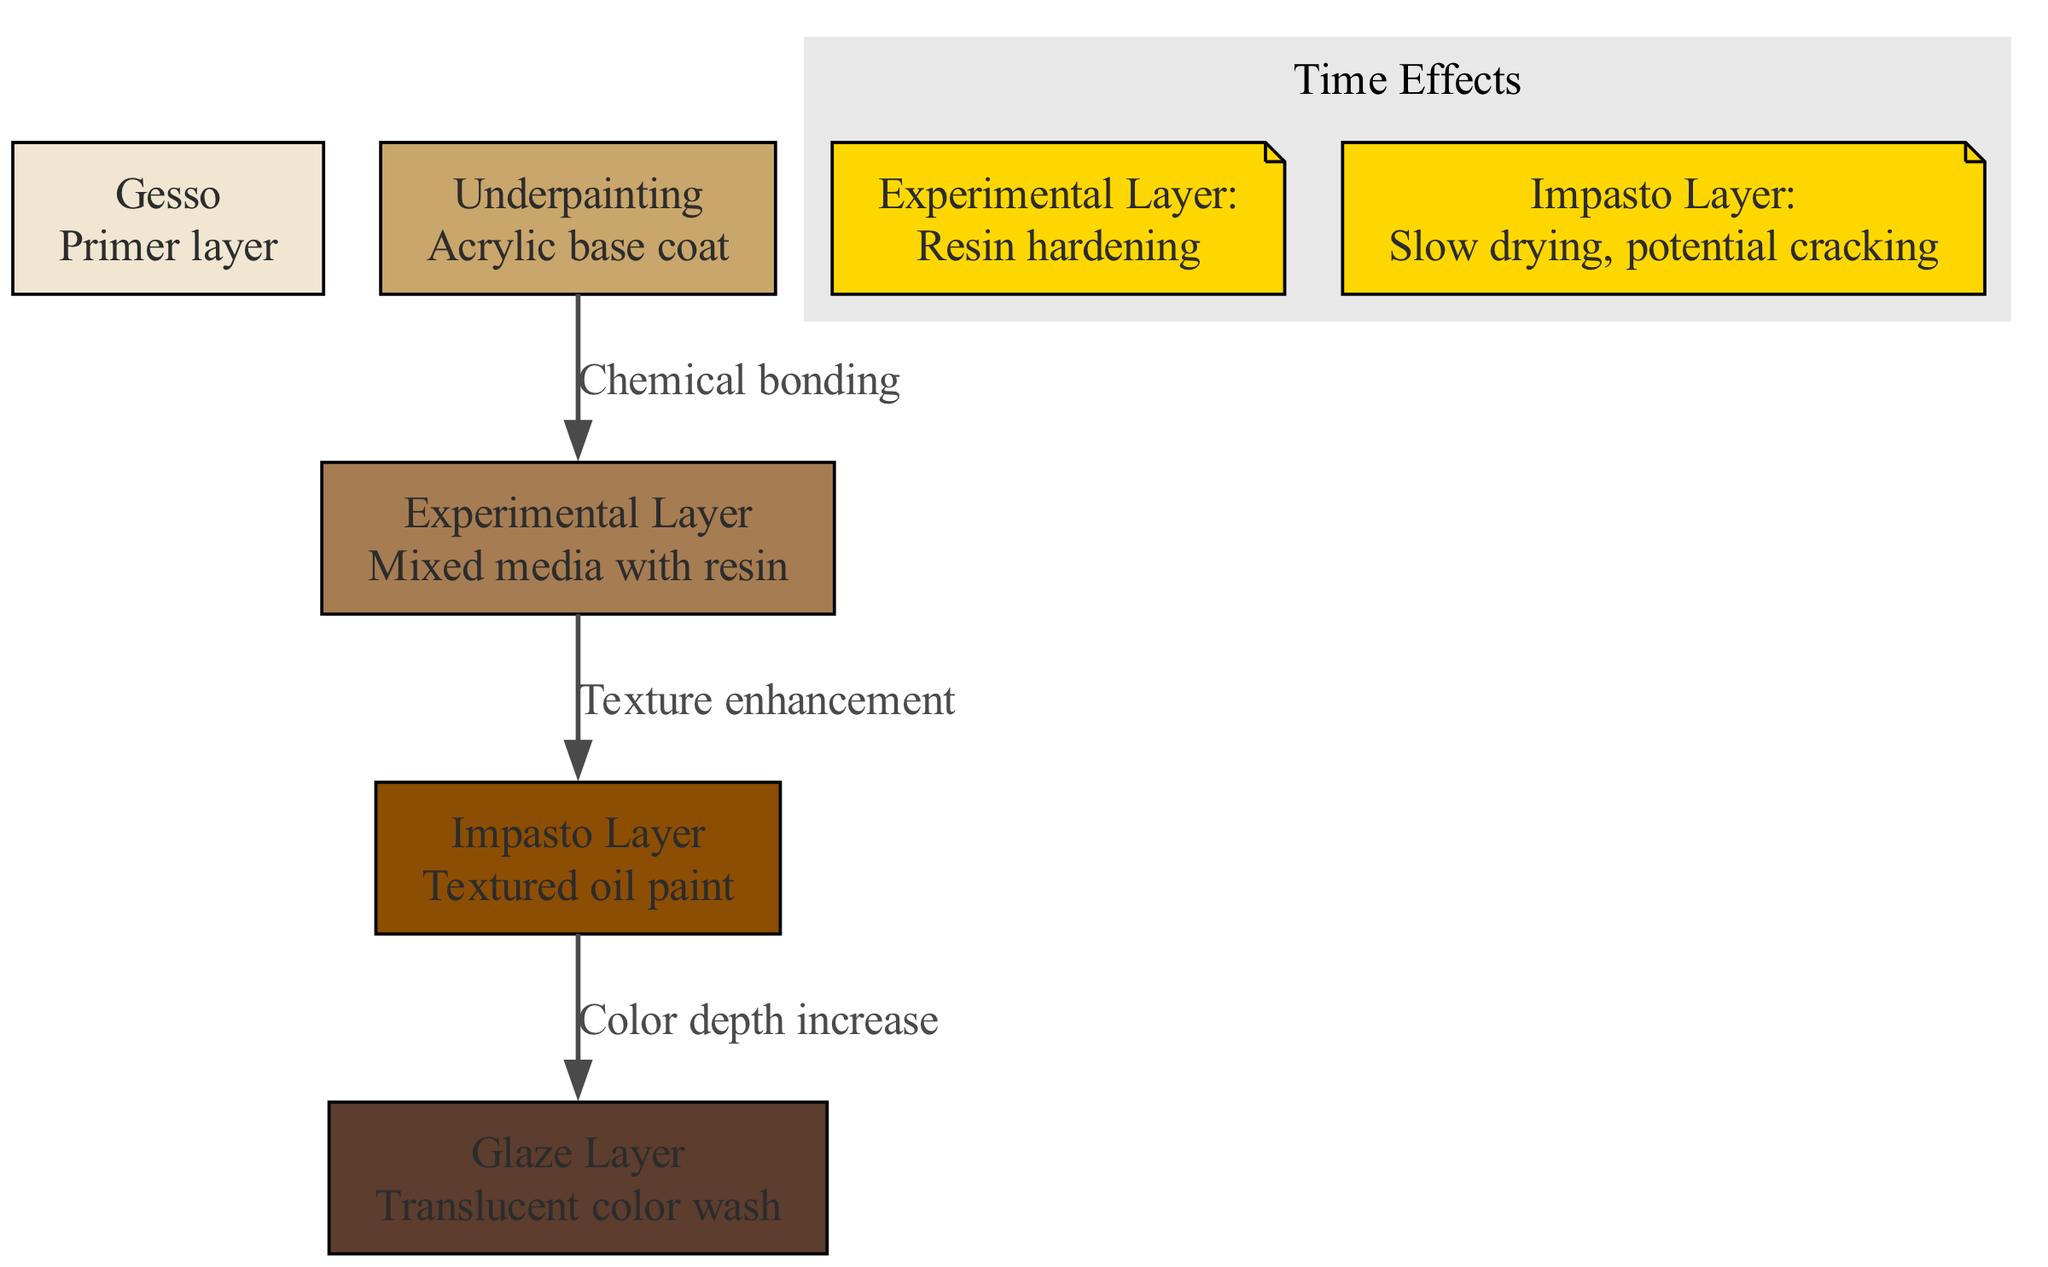What is the primer layer in the canvas cross-section? The primer layer is identified in the diagram as "Gesso." It is the base layer that prepares the canvas for subsequent layers of paint.
Answer: Gesso How many layers are there in total? The diagram lists five distinct layers in the canvas. This can be counted directly from the nodes representing each layer.
Answer: 5 What interaction occurs between the Underpainting and the Experimental Layer? The interaction label between these two layers states "Chemical bonding." This shows a key relationship that affects how these layers adhere to each other, which is visible in the edge label.
Answer: Chemical bonding Which layer is associated with slow drying and potential cracking? According to the "Time Effects" subgraph in the diagram, the "Impasto Layer" is noted for having slow drying and potential cracking over time.
Answer: Impasto Layer What is the effect of the interaction between the Impasto Layer and the Glaze Layer? The interaction between these two layers is defined in the diagram as "Color depth increase," which indicates how these layers enhance the visual quality of the painting.
Answer: Color depth increase Which layer introduces a mixed media with resin? The layer referred to in the diagram as "Experimental Layer" is noted for using mixed media incorporating resin, distinguishing its composition from other layers.
Answer: Experimental Layer How does the Experimental Layer change over time? The diagram specifies that the "Experimental Layer" undergoes "Resin hardening" over time, indicating a significant transformation that affects its structural integrity.
Answer: Resin hardening What is the relationship between the Experimental Layer and the Impasto Layer? The diagram displays the connection between these two layers under the effect "Texture enhancement," which shows the impact these layers have on the overall texture of the artwork.
Answer: Texture enhancement What color is the Glaze Layer represented in the diagram? The Glaze Layer is represented by a specific color in the diagram, which appears to be associated with a particular color assigned in its node; this can be inferred visually.
Answer: (color code indicated) 